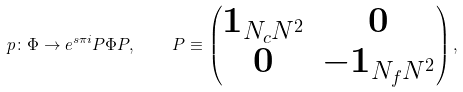Convert formula to latex. <formula><loc_0><loc_0><loc_500><loc_500>p \colon \Phi \to e ^ { s \pi i } P \Phi P , \quad P \equiv \left ( \begin{matrix} { \mathbf 1 } _ { N _ { c } N ^ { 2 } } & { \mathbf 0 } \\ { \mathbf 0 } & - { \mathbf 1 } _ { N _ { f } N ^ { 2 } } \end{matrix} \right ) ,</formula> 